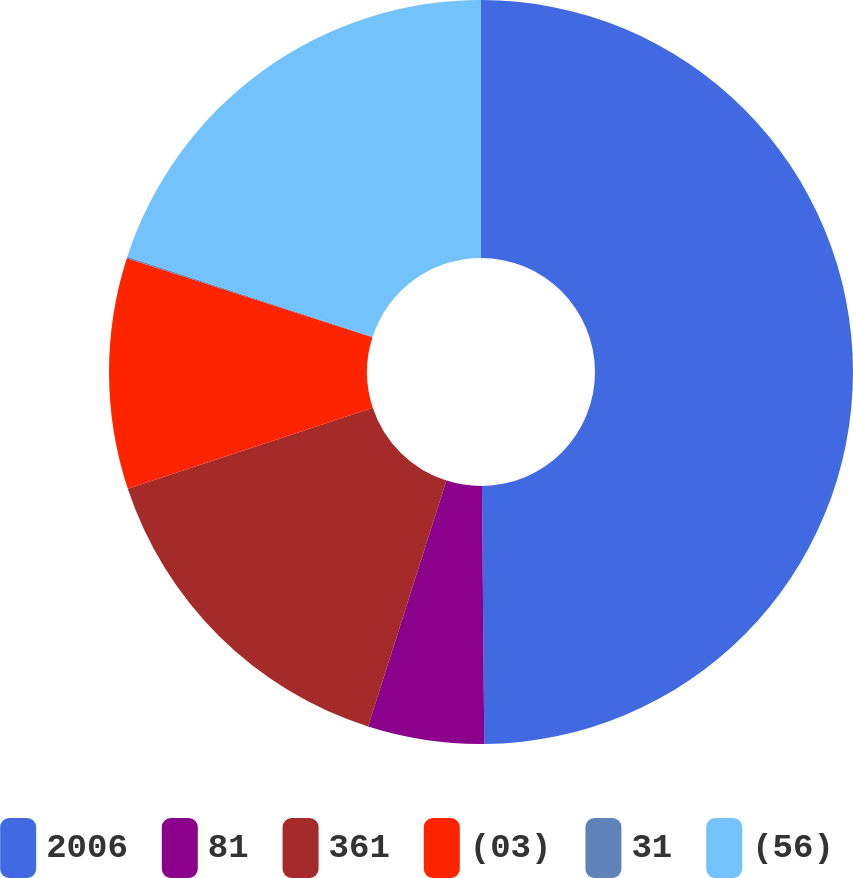Convert chart to OTSL. <chart><loc_0><loc_0><loc_500><loc_500><pie_chart><fcel>2006<fcel>81<fcel>361<fcel>(03)<fcel>31<fcel>(56)<nl><fcel>49.87%<fcel>5.05%<fcel>15.01%<fcel>10.03%<fcel>0.07%<fcel>19.99%<nl></chart> 